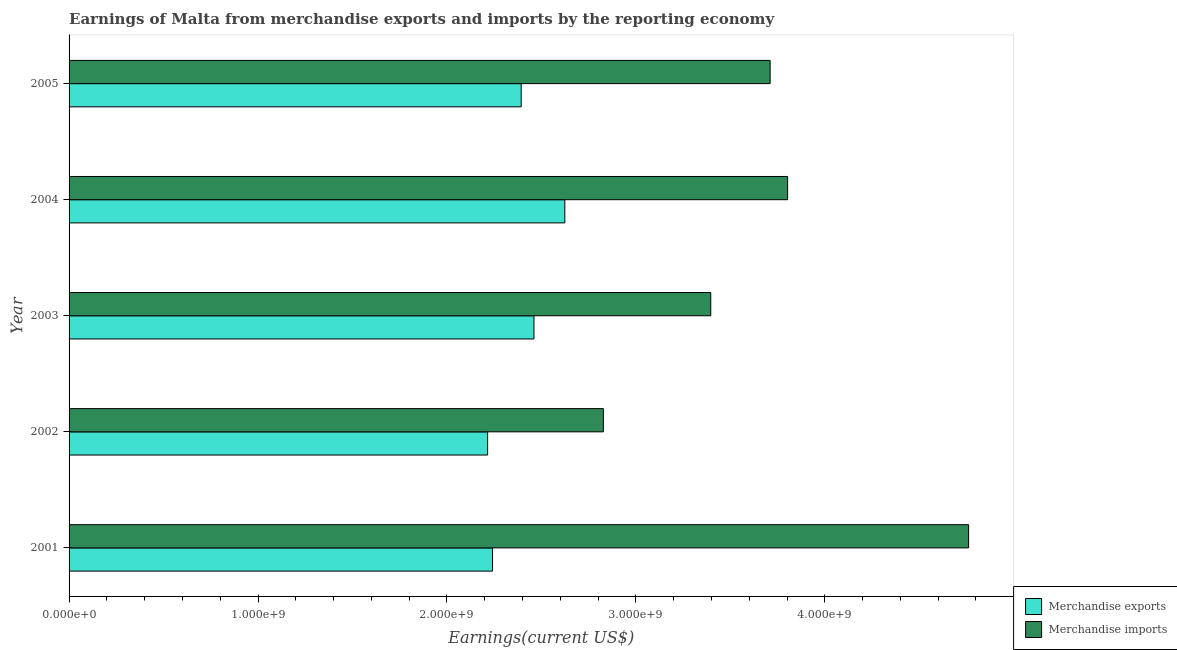How many groups of bars are there?
Your response must be concise. 5. Are the number of bars per tick equal to the number of legend labels?
Ensure brevity in your answer.  Yes. Are the number of bars on each tick of the Y-axis equal?
Your answer should be compact. Yes. What is the earnings from merchandise imports in 2005?
Offer a very short reply. 3.71e+09. Across all years, what is the maximum earnings from merchandise exports?
Keep it short and to the point. 2.62e+09. Across all years, what is the minimum earnings from merchandise imports?
Offer a very short reply. 2.83e+09. In which year was the earnings from merchandise exports maximum?
Give a very brief answer. 2004. In which year was the earnings from merchandise exports minimum?
Provide a short and direct response. 2002. What is the total earnings from merchandise exports in the graph?
Give a very brief answer. 1.19e+1. What is the difference between the earnings from merchandise imports in 2001 and that in 2004?
Keep it short and to the point. 9.58e+08. What is the difference between the earnings from merchandise imports in 2002 and the earnings from merchandise exports in 2004?
Offer a terse response. 2.04e+08. What is the average earnings from merchandise exports per year?
Ensure brevity in your answer.  2.39e+09. In the year 2005, what is the difference between the earnings from merchandise imports and earnings from merchandise exports?
Your answer should be very brief. 1.32e+09. In how many years, is the earnings from merchandise imports greater than 1400000000 US$?
Provide a short and direct response. 5. What is the ratio of the earnings from merchandise exports in 2002 to that in 2005?
Offer a very short reply. 0.93. What is the difference between the highest and the second highest earnings from merchandise imports?
Ensure brevity in your answer.  9.58e+08. What is the difference between the highest and the lowest earnings from merchandise exports?
Keep it short and to the point. 4.09e+08. What does the 1st bar from the top in 2002 represents?
Give a very brief answer. Merchandise imports. How many bars are there?
Offer a terse response. 10. How many years are there in the graph?
Provide a succinct answer. 5. What is the difference between two consecutive major ticks on the X-axis?
Offer a terse response. 1.00e+09. Does the graph contain grids?
Your answer should be very brief. No. How many legend labels are there?
Offer a terse response. 2. What is the title of the graph?
Provide a succinct answer. Earnings of Malta from merchandise exports and imports by the reporting economy. Does "Male labor force" appear as one of the legend labels in the graph?
Make the answer very short. No. What is the label or title of the X-axis?
Make the answer very short. Earnings(current US$). What is the label or title of the Y-axis?
Your answer should be compact. Year. What is the Earnings(current US$) in Merchandise exports in 2001?
Your answer should be very brief. 2.24e+09. What is the Earnings(current US$) in Merchandise imports in 2001?
Provide a succinct answer. 4.76e+09. What is the Earnings(current US$) in Merchandise exports in 2002?
Your answer should be compact. 2.22e+09. What is the Earnings(current US$) in Merchandise imports in 2002?
Provide a succinct answer. 2.83e+09. What is the Earnings(current US$) of Merchandise exports in 2003?
Make the answer very short. 2.46e+09. What is the Earnings(current US$) in Merchandise imports in 2003?
Your answer should be compact. 3.40e+09. What is the Earnings(current US$) in Merchandise exports in 2004?
Provide a succinct answer. 2.62e+09. What is the Earnings(current US$) in Merchandise imports in 2004?
Give a very brief answer. 3.80e+09. What is the Earnings(current US$) in Merchandise exports in 2005?
Keep it short and to the point. 2.39e+09. What is the Earnings(current US$) of Merchandise imports in 2005?
Ensure brevity in your answer.  3.71e+09. Across all years, what is the maximum Earnings(current US$) of Merchandise exports?
Offer a very short reply. 2.62e+09. Across all years, what is the maximum Earnings(current US$) of Merchandise imports?
Your answer should be compact. 4.76e+09. Across all years, what is the minimum Earnings(current US$) in Merchandise exports?
Offer a terse response. 2.22e+09. Across all years, what is the minimum Earnings(current US$) in Merchandise imports?
Your answer should be very brief. 2.83e+09. What is the total Earnings(current US$) of Merchandise exports in the graph?
Keep it short and to the point. 1.19e+1. What is the total Earnings(current US$) of Merchandise imports in the graph?
Your response must be concise. 1.85e+1. What is the difference between the Earnings(current US$) in Merchandise exports in 2001 and that in 2002?
Make the answer very short. 2.60e+07. What is the difference between the Earnings(current US$) in Merchandise imports in 2001 and that in 2002?
Offer a terse response. 1.93e+09. What is the difference between the Earnings(current US$) of Merchandise exports in 2001 and that in 2003?
Make the answer very short. -2.19e+08. What is the difference between the Earnings(current US$) of Merchandise imports in 2001 and that in 2003?
Your response must be concise. 1.36e+09. What is the difference between the Earnings(current US$) of Merchandise exports in 2001 and that in 2004?
Provide a succinct answer. -3.83e+08. What is the difference between the Earnings(current US$) in Merchandise imports in 2001 and that in 2004?
Keep it short and to the point. 9.58e+08. What is the difference between the Earnings(current US$) of Merchandise exports in 2001 and that in 2005?
Keep it short and to the point. -1.52e+08. What is the difference between the Earnings(current US$) in Merchandise imports in 2001 and that in 2005?
Provide a succinct answer. 1.05e+09. What is the difference between the Earnings(current US$) in Merchandise exports in 2002 and that in 2003?
Give a very brief answer. -2.45e+08. What is the difference between the Earnings(current US$) of Merchandise imports in 2002 and that in 2003?
Ensure brevity in your answer.  -5.68e+08. What is the difference between the Earnings(current US$) in Merchandise exports in 2002 and that in 2004?
Keep it short and to the point. -4.09e+08. What is the difference between the Earnings(current US$) in Merchandise imports in 2002 and that in 2004?
Offer a terse response. -9.75e+08. What is the difference between the Earnings(current US$) in Merchandise exports in 2002 and that in 2005?
Offer a very short reply. -1.78e+08. What is the difference between the Earnings(current US$) in Merchandise imports in 2002 and that in 2005?
Your answer should be very brief. -8.83e+08. What is the difference between the Earnings(current US$) of Merchandise exports in 2003 and that in 2004?
Your response must be concise. -1.63e+08. What is the difference between the Earnings(current US$) of Merchandise imports in 2003 and that in 2004?
Your answer should be very brief. -4.07e+08. What is the difference between the Earnings(current US$) of Merchandise exports in 2003 and that in 2005?
Provide a short and direct response. 6.77e+07. What is the difference between the Earnings(current US$) in Merchandise imports in 2003 and that in 2005?
Keep it short and to the point. -3.14e+08. What is the difference between the Earnings(current US$) in Merchandise exports in 2004 and that in 2005?
Your answer should be very brief. 2.31e+08. What is the difference between the Earnings(current US$) of Merchandise imports in 2004 and that in 2005?
Make the answer very short. 9.26e+07. What is the difference between the Earnings(current US$) in Merchandise exports in 2001 and the Earnings(current US$) in Merchandise imports in 2002?
Your response must be concise. -5.87e+08. What is the difference between the Earnings(current US$) of Merchandise exports in 2001 and the Earnings(current US$) of Merchandise imports in 2003?
Your answer should be very brief. -1.16e+09. What is the difference between the Earnings(current US$) in Merchandise exports in 2001 and the Earnings(current US$) in Merchandise imports in 2004?
Your response must be concise. -1.56e+09. What is the difference between the Earnings(current US$) of Merchandise exports in 2001 and the Earnings(current US$) of Merchandise imports in 2005?
Provide a succinct answer. -1.47e+09. What is the difference between the Earnings(current US$) in Merchandise exports in 2002 and the Earnings(current US$) in Merchandise imports in 2003?
Offer a very short reply. -1.18e+09. What is the difference between the Earnings(current US$) of Merchandise exports in 2002 and the Earnings(current US$) of Merchandise imports in 2004?
Your response must be concise. -1.59e+09. What is the difference between the Earnings(current US$) of Merchandise exports in 2002 and the Earnings(current US$) of Merchandise imports in 2005?
Ensure brevity in your answer.  -1.50e+09. What is the difference between the Earnings(current US$) in Merchandise exports in 2003 and the Earnings(current US$) in Merchandise imports in 2004?
Your answer should be compact. -1.34e+09. What is the difference between the Earnings(current US$) in Merchandise exports in 2003 and the Earnings(current US$) in Merchandise imports in 2005?
Keep it short and to the point. -1.25e+09. What is the difference between the Earnings(current US$) in Merchandise exports in 2004 and the Earnings(current US$) in Merchandise imports in 2005?
Your answer should be compact. -1.09e+09. What is the average Earnings(current US$) of Merchandise exports per year?
Make the answer very short. 2.39e+09. What is the average Earnings(current US$) of Merchandise imports per year?
Ensure brevity in your answer.  3.70e+09. In the year 2001, what is the difference between the Earnings(current US$) in Merchandise exports and Earnings(current US$) in Merchandise imports?
Offer a very short reply. -2.52e+09. In the year 2002, what is the difference between the Earnings(current US$) in Merchandise exports and Earnings(current US$) in Merchandise imports?
Make the answer very short. -6.13e+08. In the year 2003, what is the difference between the Earnings(current US$) in Merchandise exports and Earnings(current US$) in Merchandise imports?
Keep it short and to the point. -9.36e+08. In the year 2004, what is the difference between the Earnings(current US$) of Merchandise exports and Earnings(current US$) of Merchandise imports?
Provide a succinct answer. -1.18e+09. In the year 2005, what is the difference between the Earnings(current US$) of Merchandise exports and Earnings(current US$) of Merchandise imports?
Make the answer very short. -1.32e+09. What is the ratio of the Earnings(current US$) of Merchandise exports in 2001 to that in 2002?
Provide a short and direct response. 1.01. What is the ratio of the Earnings(current US$) of Merchandise imports in 2001 to that in 2002?
Give a very brief answer. 1.68. What is the ratio of the Earnings(current US$) of Merchandise exports in 2001 to that in 2003?
Your response must be concise. 0.91. What is the ratio of the Earnings(current US$) in Merchandise imports in 2001 to that in 2003?
Your answer should be very brief. 1.4. What is the ratio of the Earnings(current US$) of Merchandise exports in 2001 to that in 2004?
Ensure brevity in your answer.  0.85. What is the ratio of the Earnings(current US$) in Merchandise imports in 2001 to that in 2004?
Make the answer very short. 1.25. What is the ratio of the Earnings(current US$) in Merchandise exports in 2001 to that in 2005?
Provide a succinct answer. 0.94. What is the ratio of the Earnings(current US$) of Merchandise imports in 2001 to that in 2005?
Make the answer very short. 1.28. What is the ratio of the Earnings(current US$) in Merchandise exports in 2002 to that in 2003?
Your answer should be very brief. 0.9. What is the ratio of the Earnings(current US$) of Merchandise imports in 2002 to that in 2003?
Provide a short and direct response. 0.83. What is the ratio of the Earnings(current US$) in Merchandise exports in 2002 to that in 2004?
Your response must be concise. 0.84. What is the ratio of the Earnings(current US$) in Merchandise imports in 2002 to that in 2004?
Offer a terse response. 0.74. What is the ratio of the Earnings(current US$) in Merchandise exports in 2002 to that in 2005?
Ensure brevity in your answer.  0.93. What is the ratio of the Earnings(current US$) of Merchandise imports in 2002 to that in 2005?
Give a very brief answer. 0.76. What is the ratio of the Earnings(current US$) in Merchandise exports in 2003 to that in 2004?
Keep it short and to the point. 0.94. What is the ratio of the Earnings(current US$) in Merchandise imports in 2003 to that in 2004?
Offer a terse response. 0.89. What is the ratio of the Earnings(current US$) of Merchandise exports in 2003 to that in 2005?
Provide a short and direct response. 1.03. What is the ratio of the Earnings(current US$) in Merchandise imports in 2003 to that in 2005?
Your answer should be very brief. 0.92. What is the ratio of the Earnings(current US$) in Merchandise exports in 2004 to that in 2005?
Offer a very short reply. 1.1. What is the ratio of the Earnings(current US$) of Merchandise imports in 2004 to that in 2005?
Offer a very short reply. 1.02. What is the difference between the highest and the second highest Earnings(current US$) in Merchandise exports?
Keep it short and to the point. 1.63e+08. What is the difference between the highest and the second highest Earnings(current US$) in Merchandise imports?
Provide a short and direct response. 9.58e+08. What is the difference between the highest and the lowest Earnings(current US$) in Merchandise exports?
Provide a succinct answer. 4.09e+08. What is the difference between the highest and the lowest Earnings(current US$) in Merchandise imports?
Your answer should be very brief. 1.93e+09. 